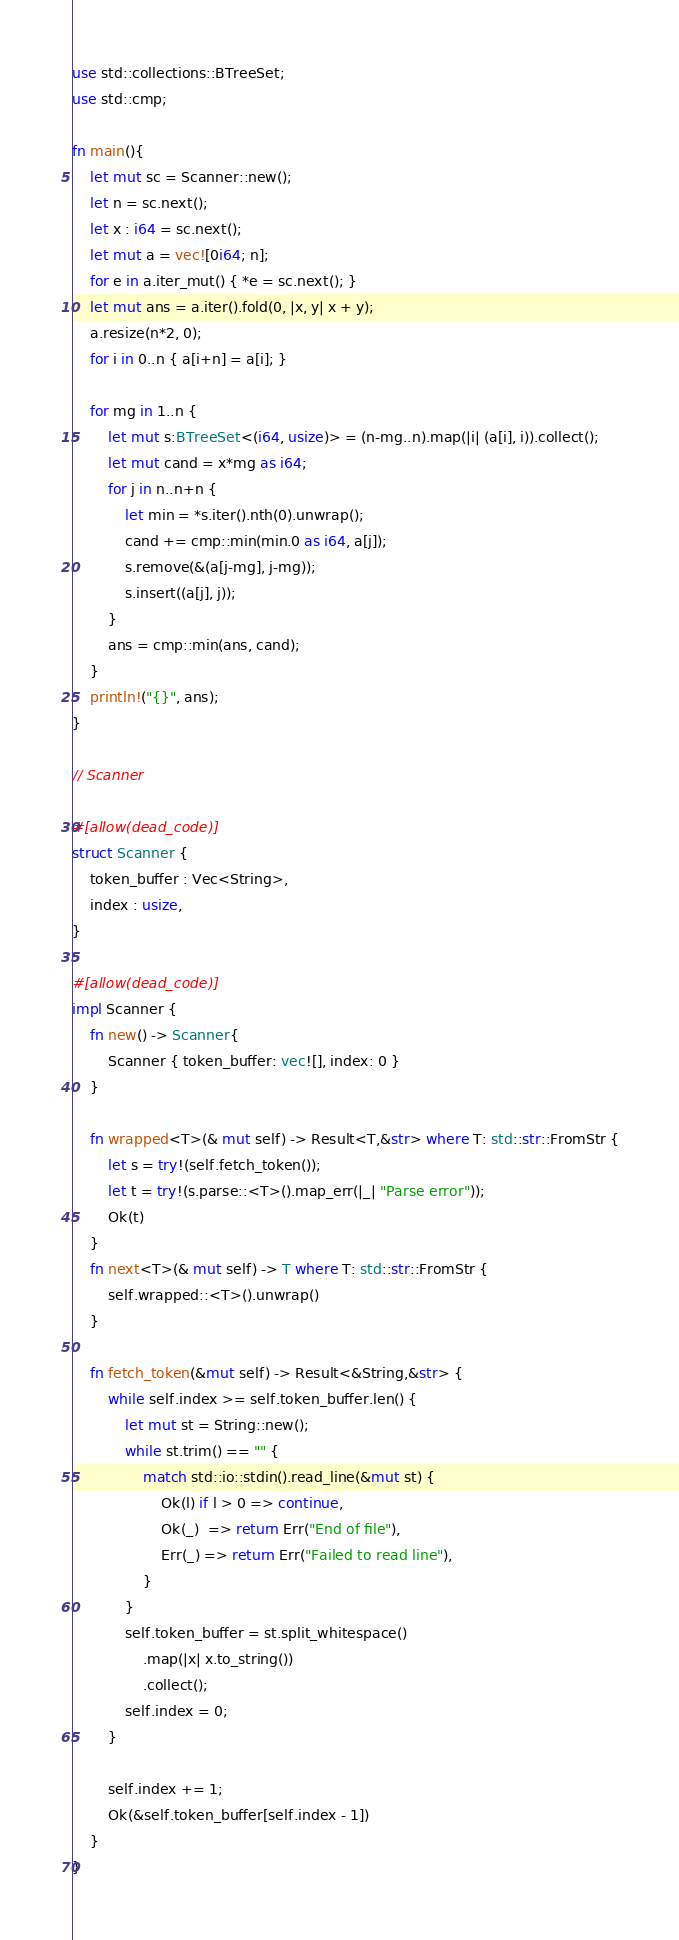<code> <loc_0><loc_0><loc_500><loc_500><_Rust_>use std::collections::BTreeSet;
use std::cmp;

fn main(){
    let mut sc = Scanner::new();
    let n = sc.next();
    let x : i64 = sc.next();
    let mut a = vec![0i64; n];
    for e in a.iter_mut() { *e = sc.next(); }
    let mut ans = a.iter().fold(0, |x, y| x + y);
    a.resize(n*2, 0);
    for i in 0..n { a[i+n] = a[i]; }

    for mg in 1..n {
        let mut s:BTreeSet<(i64, usize)> = (n-mg..n).map(|i| (a[i], i)).collect();
        let mut cand = x*mg as i64;
        for j in n..n+n {
            let min = *s.iter().nth(0).unwrap();
            cand += cmp::min(min.0 as i64, a[j]);
            s.remove(&(a[j-mg], j-mg));
            s.insert((a[j], j));
        }
        ans = cmp::min(ans, cand);
    }
    println!("{}", ans);
}

// Scanner

#[allow(dead_code)]
struct Scanner {
    token_buffer : Vec<String>,
    index : usize,
}

#[allow(dead_code)]
impl Scanner {
    fn new() -> Scanner{
        Scanner { token_buffer: vec![], index: 0 }
    }

    fn wrapped<T>(& mut self) -> Result<T,&str> where T: std::str::FromStr {
        let s = try!(self.fetch_token());
        let t = try!(s.parse::<T>().map_err(|_| "Parse error"));
        Ok(t)
    }
    fn next<T>(& mut self) -> T where T: std::str::FromStr {
        self.wrapped::<T>().unwrap()
    }

    fn fetch_token(&mut self) -> Result<&String,&str> {
        while self.index >= self.token_buffer.len() {
            let mut st = String::new();
            while st.trim() == "" {
                match std::io::stdin().read_line(&mut st) {
                    Ok(l) if l > 0 => continue,
                    Ok(_)  => return Err("End of file"),
                    Err(_) => return Err("Failed to read line"),
                }
            }
            self.token_buffer = st.split_whitespace()
                .map(|x| x.to_string())
                .collect();
            self.index = 0;
        }

        self.index += 1;
        Ok(&self.token_buffer[self.index - 1])
    }
}
</code> 